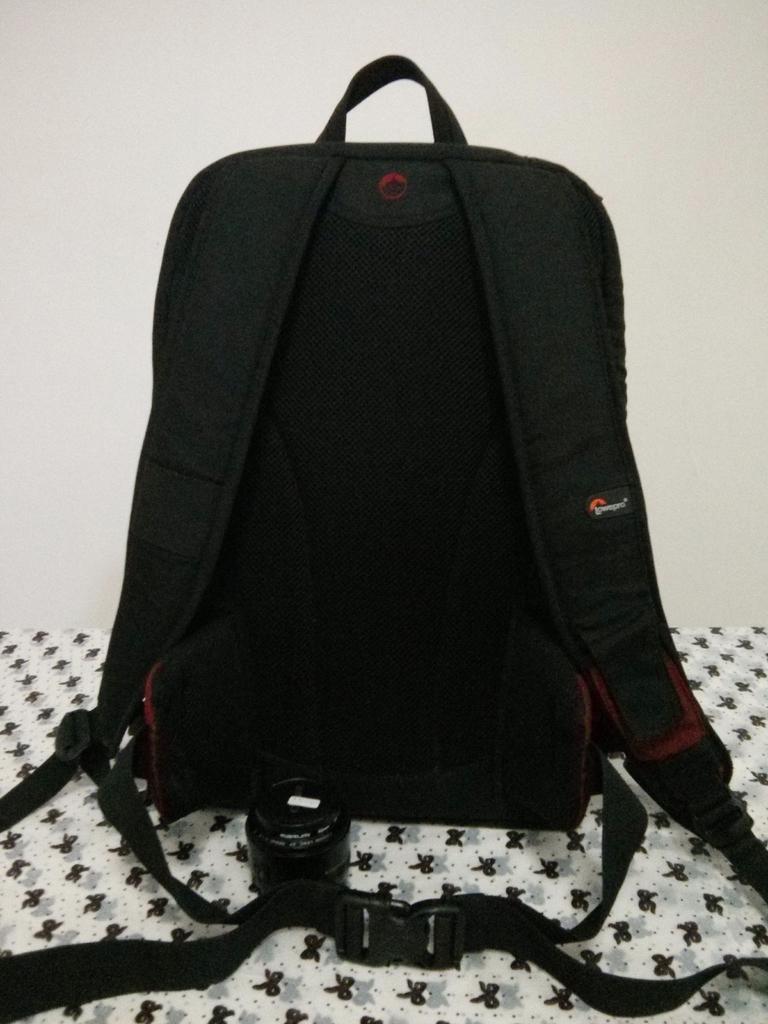Describe this image in one or two sentences. In this Image I see a black colored bag and In the background I see cream colored wall. 